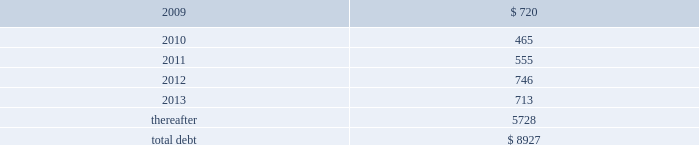Debt maturities 2013 the table presents aggregate debt maturities as of december 31 , 2008 , excluding market value adjustments .
Millions of dollars .
As of december 31 , 2008 , we have reclassified as long-term debt approximately $ 400 million of debt due within one year that we intend to refinance .
This reclassification reflects our ability and intent to refinance any short-term borrowings and certain current maturities of long-term debt on a long-term basis .
At december 31 , 2007 , we reclassified as long-term debt approximately $ 550 million of debt due within one year that we intended to refinance at that time .
Mortgaged properties 2013 equipment with a carrying value of approximately $ 2.7 billion and $ 2.8 billion at december 31 , 2008 and 2007 , respectively , serves as collateral for capital leases and other types of equipment obligations in accordance with the secured financing arrangements utilized to acquire such railroad equipment .
As a result of the merger of missouri pacific railroad company ( mprr ) with and into uprr on january 1 , 1997 , and pursuant to the underlying indentures for the mprr mortgage bonds , uprr must maintain the same value of assets after the merger in order to comply with the security requirements of the mortgage bonds .
As of the merger date , the value of the mprr assets that secured the mortgage bonds was approximately $ 6.0 billion .
In accordance with the terms of the indentures , this collateral value must be maintained during the entire term of the mortgage bonds irrespective of the outstanding balance of such bonds .
Credit facilities 2013 on december 31 , 2008 , we had $ 1.9 billion of credit available under our revolving credit facility ( the facility ) .
The facility is designated for general corporate purposes and supports the issuance of commercial paper .
We did not draw on the facility during 2008 .
Commitment fees and interest rates payable under the facility are similar to fees and rates available to comparably rated , investment- grade borrowers .
The facility allows borrowings at floating rates based on london interbank offered rates , plus a spread , depending upon our senior unsecured debt ratings .
The facility requires union pacific corporation to maintain a debt-to-net-worth coverage ratio as a condition to making a borrowing .
At december 31 , 2008 , and december 31 , 2007 ( and at all times during these periods ) , we were in compliance with this covenant .
The definition of debt used for purposes of calculating the debt-to-net-worth coverage ratio includes , among other things , certain credit arrangements , capital leases , guarantees and unfunded and vested pension benefits under title iv of erisa .
At december 31 , 2008 , the debt-to-net-worth coverage ratio allowed us to carry up to $ 30.9 billion of debt ( as defined in the facility ) , and we had $ 9.9 billion of debt ( as defined in the facility ) outstanding at that date .
Under our current capital plans , we expect to continue to satisfy the debt-to-net-worth coverage ratio ; however , many factors beyond our reasonable control ( including the risk factors in item 1a of this report ) could affect our ability to comply with this provision in the future .
The facility does not include any other financial restrictions , credit rating triggers ( other than rating-dependent pricing ) , or any other provision that could require us to post collateral .
The .
As of december 31 , 2008 what was the percent of the total aggregate debt maturities that was due in 2012? 
Computations: (746 / 8927)
Answer: 0.08357. Debt maturities 2013 the table presents aggregate debt maturities as of december 31 , 2008 , excluding market value adjustments .
Millions of dollars .
As of december 31 , 2008 , we have reclassified as long-term debt approximately $ 400 million of debt due within one year that we intend to refinance .
This reclassification reflects our ability and intent to refinance any short-term borrowings and certain current maturities of long-term debt on a long-term basis .
At december 31 , 2007 , we reclassified as long-term debt approximately $ 550 million of debt due within one year that we intended to refinance at that time .
Mortgaged properties 2013 equipment with a carrying value of approximately $ 2.7 billion and $ 2.8 billion at december 31 , 2008 and 2007 , respectively , serves as collateral for capital leases and other types of equipment obligations in accordance with the secured financing arrangements utilized to acquire such railroad equipment .
As a result of the merger of missouri pacific railroad company ( mprr ) with and into uprr on january 1 , 1997 , and pursuant to the underlying indentures for the mprr mortgage bonds , uprr must maintain the same value of assets after the merger in order to comply with the security requirements of the mortgage bonds .
As of the merger date , the value of the mprr assets that secured the mortgage bonds was approximately $ 6.0 billion .
In accordance with the terms of the indentures , this collateral value must be maintained during the entire term of the mortgage bonds irrespective of the outstanding balance of such bonds .
Credit facilities 2013 on december 31 , 2008 , we had $ 1.9 billion of credit available under our revolving credit facility ( the facility ) .
The facility is designated for general corporate purposes and supports the issuance of commercial paper .
We did not draw on the facility during 2008 .
Commitment fees and interest rates payable under the facility are similar to fees and rates available to comparably rated , investment- grade borrowers .
The facility allows borrowings at floating rates based on london interbank offered rates , plus a spread , depending upon our senior unsecured debt ratings .
The facility requires union pacific corporation to maintain a debt-to-net-worth coverage ratio as a condition to making a borrowing .
At december 31 , 2008 , and december 31 , 2007 ( and at all times during these periods ) , we were in compliance with this covenant .
The definition of debt used for purposes of calculating the debt-to-net-worth coverage ratio includes , among other things , certain credit arrangements , capital leases , guarantees and unfunded and vested pension benefits under title iv of erisa .
At december 31 , 2008 , the debt-to-net-worth coverage ratio allowed us to carry up to $ 30.9 billion of debt ( as defined in the facility ) , and we had $ 9.9 billion of debt ( as defined in the facility ) outstanding at that date .
Under our current capital plans , we expect to continue to satisfy the debt-to-net-worth coverage ratio ; however , many factors beyond our reasonable control ( including the risk factors in item 1a of this report ) could affect our ability to comply with this provision in the future .
The facility does not include any other financial restrictions , credit rating triggers ( other than rating-dependent pricing ) , or any other provision that could require us to post collateral .
The .
What percentage of total aggregate debt maturities as of december 31 , 2008 are due after 2013? 
Computations: (5728 / 8927)
Answer: 0.64165. 